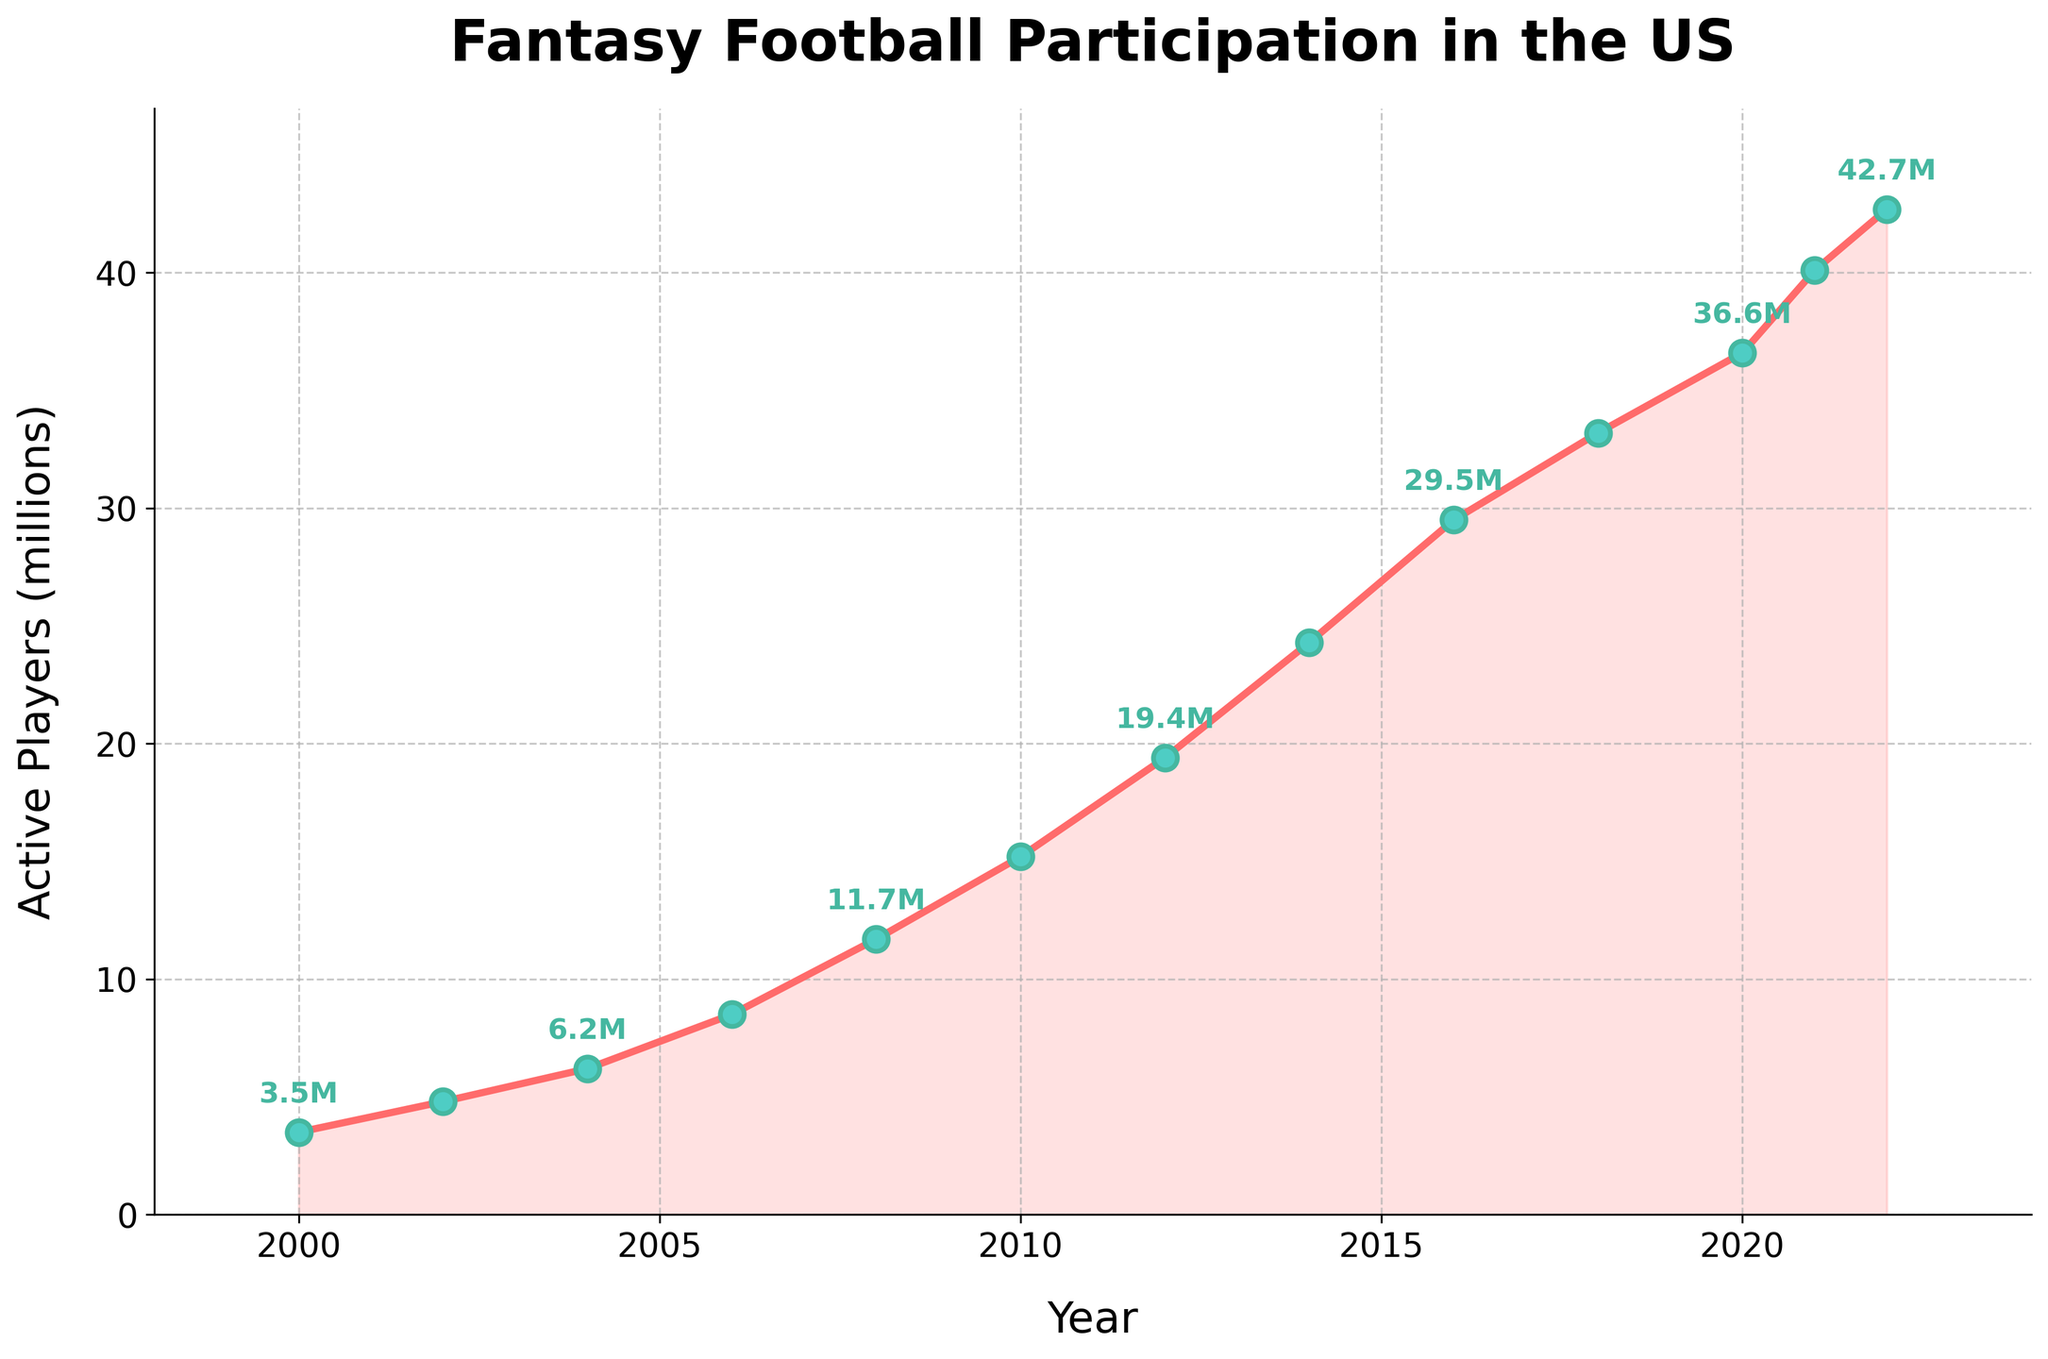What is the general trend in the number of active fantasy football players from 2000 to 2022? The line chart shows a steady increase in the number of active fantasy football players over the years. The trend is consistently upward from 2000 through 2022.
Answer: Increasing In which year did the fantasy football participation experience the highest increase compared to the previous year? By observing the steepness of the line, the largest increase occurs between 2010 and 2012. The number of active players increased from 15.2 million in 2010 to 19.4 million in 2012, which is an increase of 4.2 million.
Answer: 2010 to 2012 How many more active players were there in 2018 compared to 2008? In 2008, there were 11.7 million players, and in 2018, there were 33.2 million. The difference can be calculated as 33.2 - 11.7 = 21.5 million.
Answer: 21.5 million What is the average number of active players from 2000 to 2010? The active players for the years 2000, 2002, 2004, 2006, 2008, and 2010 are 3.5, 4.8, 6.2, 8.5, 11.7, and 15.2 million respectively. Sum these numbers: 3.5 + 4.8 + 6.2 + 8.5 + 11.7 + 15.2 = 49.9. Then, calculate the average: 49.9 / 6 = 8.3167 million.
Answer: 8.3 million Which year first saw the number of active fantasy football players surpass 30 million? According to the chart, the first year where the number of active players surpassed 30 million was in 2016 when it reached 29.5 million and then 33.2 million in 2018. So, it is in 2018.
Answer: 2018 In terms of visual attributes, how is the year 2020 prominently marked on the chart? The year 2020 is marked by a data point denoted with an "o" marker, with the data value accompanied by a light blue marker face and a darker blue marker edge, and there is an annotation "36.6M" next to this point.
Answer: "36.6M" annotation with a marker What is the percentage increase in active players from 2016 to 2022? The number of active players increased from 29.5 million in 2016 to 42.7 million in 2022. The percentage increase is calculated as ((42.7 - 29.5) / 29.5) * 100 = 44.75%.
Answer: 44.75% Which two consecutive years show the smallest change in the number of active players? By examining the line's slope and the annotated data point differences, the smallest change occurs between 2021 and 2022, increasing from 40.1 million to 42.7 million, which is 2.6 million.
Answer: 2021 and 2022 By how much did the number of active players increase from the first recorded year to the last recorded year? The number of active players in 2000 was 3.5 million, and it increased to 42.7 million in 2022. The difference is calculated as 42.7 - 3.5 = 39.2 million.
Answer: 39.2 million 